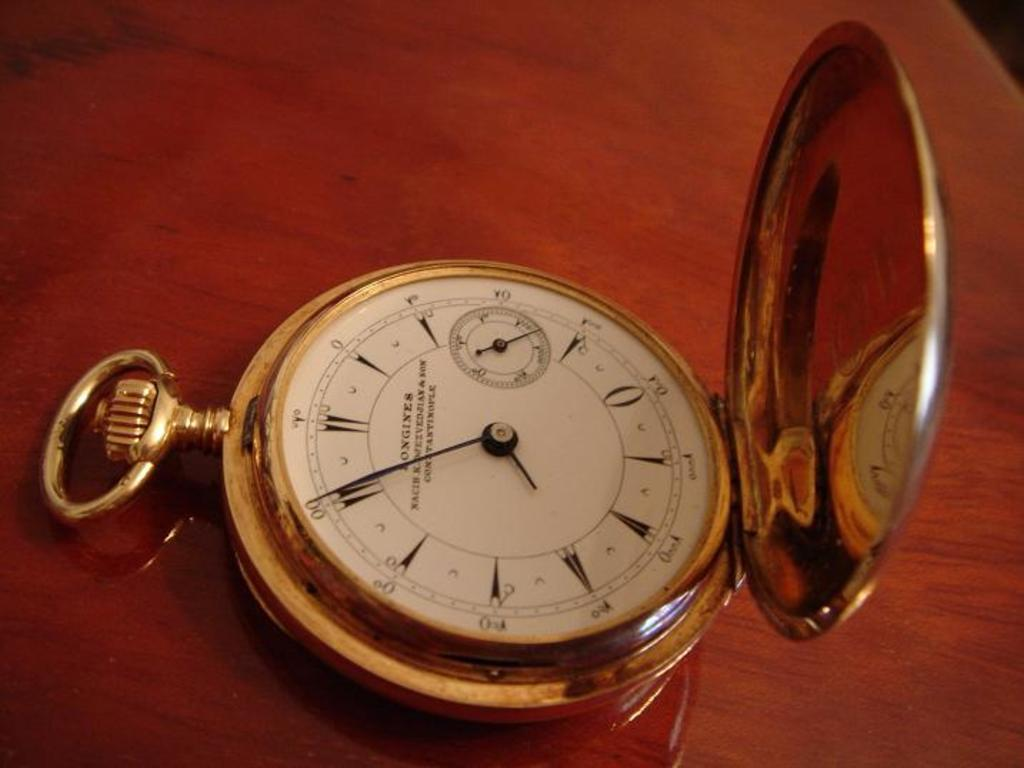<image>
Describe the image concisely. A Longines pocket watch has a gold case. 